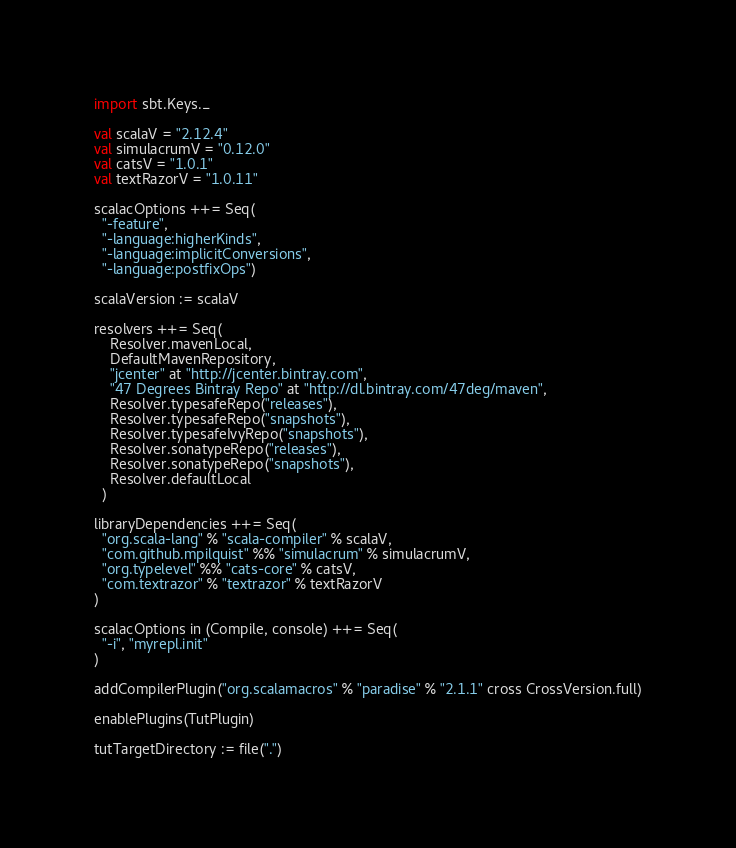<code> <loc_0><loc_0><loc_500><loc_500><_Scala_>import sbt.Keys._

val scalaV = "2.12.4"
val simulacrumV = "0.12.0"
val catsV = "1.0.1"
val textRazorV = "1.0.11"

scalacOptions ++= Seq(
  "-feature",
  "-language:higherKinds",
  "-language:implicitConversions",
  "-language:postfixOps")

scalaVersion := scalaV

resolvers ++= Seq(
    Resolver.mavenLocal,
    DefaultMavenRepository,
    "jcenter" at "http://jcenter.bintray.com",
    "47 Degrees Bintray Repo" at "http://dl.bintray.com/47deg/maven",
    Resolver.typesafeRepo("releases"),
    Resolver.typesafeRepo("snapshots"),
    Resolver.typesafeIvyRepo("snapshots"),
    Resolver.sonatypeRepo("releases"),
    Resolver.sonatypeRepo("snapshots"),
    Resolver.defaultLocal
  ) 

libraryDependencies ++= Seq(
  "org.scala-lang" % "scala-compiler" % scalaV,
  "com.github.mpilquist" %% "simulacrum" % simulacrumV,
  "org.typelevel" %% "cats-core" % catsV,
  "com.textrazor" % "textrazor" % textRazorV
)

scalacOptions in (Compile, console) ++= Seq(
  "-i", "myrepl.init"
)

addCompilerPlugin("org.scalamacros" % "paradise" % "2.1.1" cross CrossVersion.full)

enablePlugins(TutPlugin)

tutTargetDirectory := file(".")
</code> 